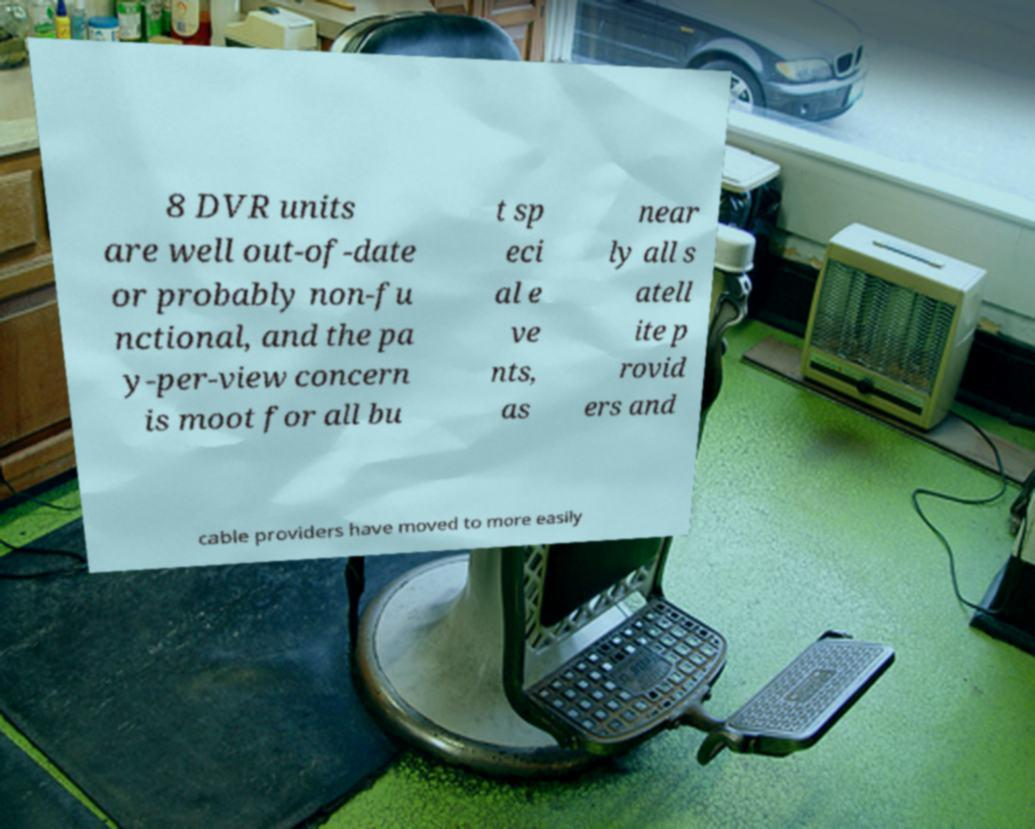For documentation purposes, I need the text within this image transcribed. Could you provide that? 8 DVR units are well out-of-date or probably non-fu nctional, and the pa y-per-view concern is moot for all bu t sp eci al e ve nts, as near ly all s atell ite p rovid ers and cable providers have moved to more easily 